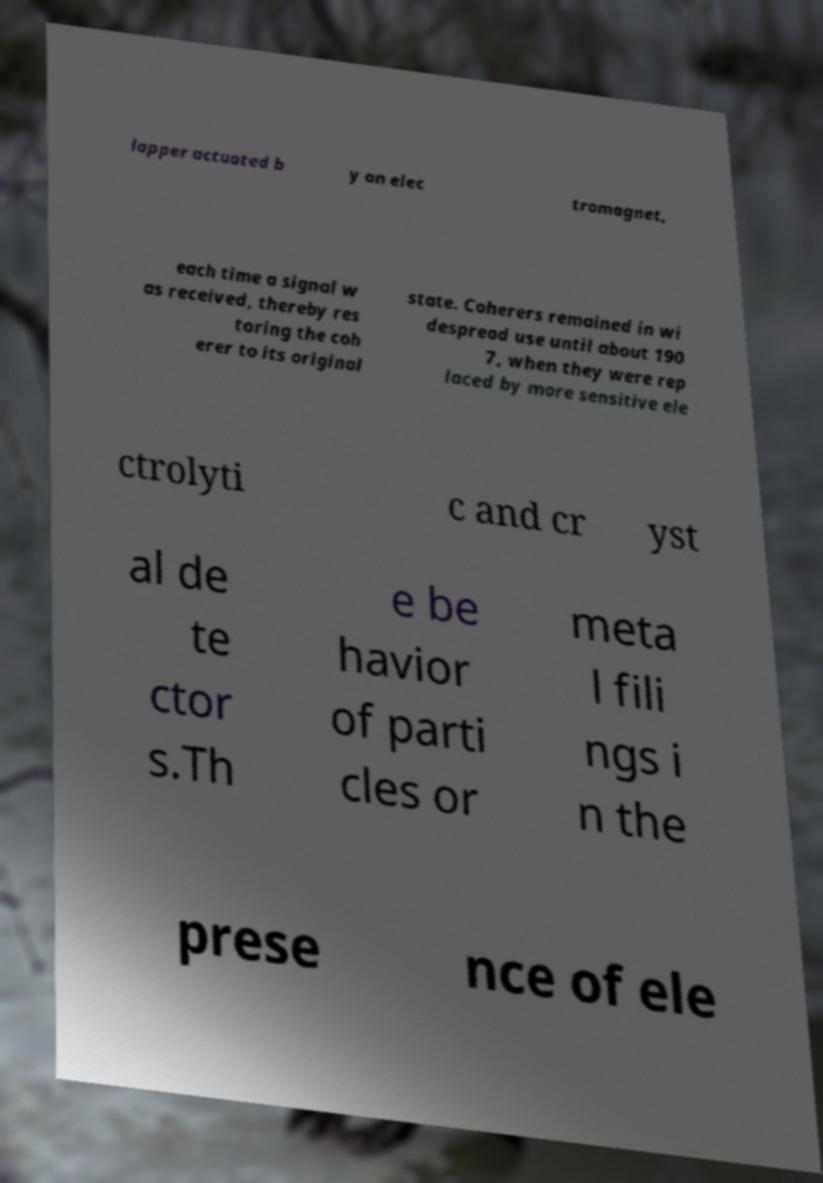For documentation purposes, I need the text within this image transcribed. Could you provide that? lapper actuated b y an elec tromagnet, each time a signal w as received, thereby res toring the coh erer to its original state. Coherers remained in wi despread use until about 190 7, when they were rep laced by more sensitive ele ctrolyti c and cr yst al de te ctor s.Th e be havior of parti cles or meta l fili ngs i n the prese nce of ele 